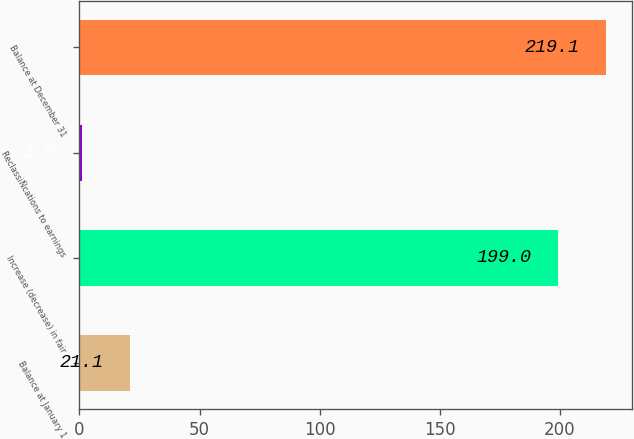Convert chart. <chart><loc_0><loc_0><loc_500><loc_500><bar_chart><fcel>Balance at January 1<fcel>Increase (decrease) in fair<fcel>ReclassiÑcations to earnings<fcel>Balance at December 31<nl><fcel>21.1<fcel>199<fcel>1<fcel>219.1<nl></chart> 